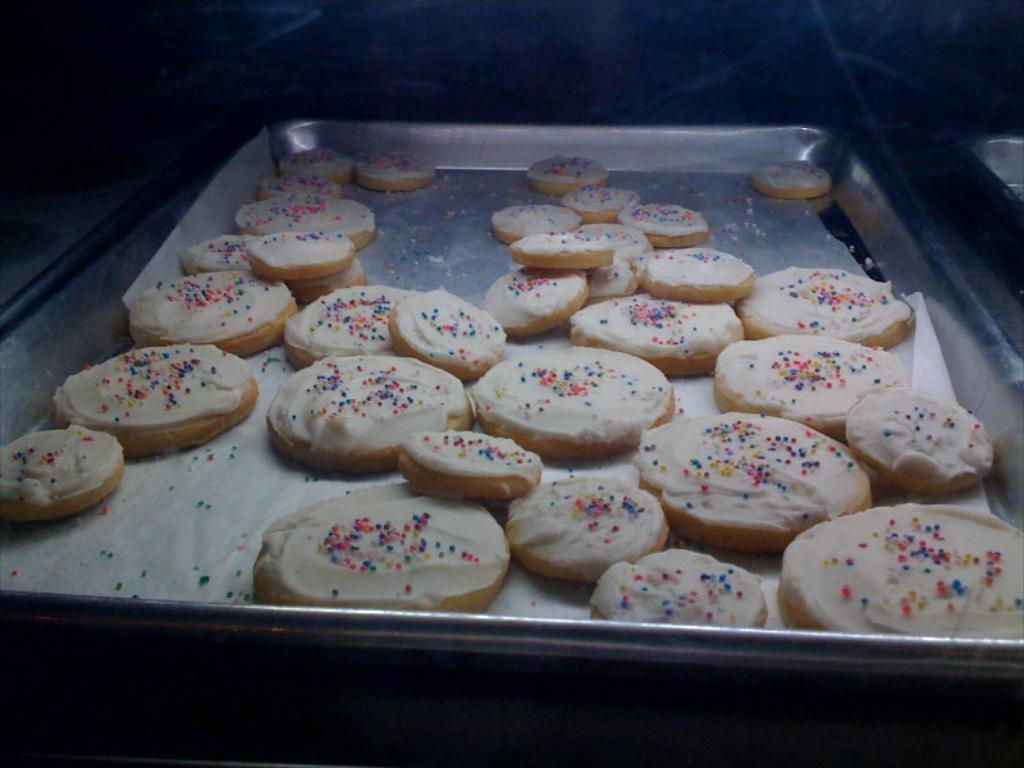In one or two sentences, can you explain what this image depicts? In this image I can see a steel plate and in it I can see number of cream colour cookies. I can also see this image is little bit in dark from background. 